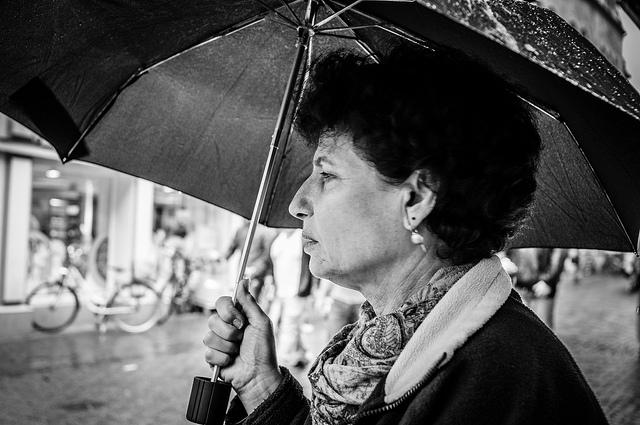Is it raining?
Short answer required. Yes. What is the lady in this picture doing?
Write a very short answer. Holding umbrella. Is the woman happy?
Keep it brief. No. 